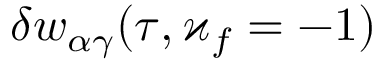<formula> <loc_0><loc_0><loc_500><loc_500>\delta w _ { \alpha \gamma } ( \tau , \varkappa _ { f } = - 1 )</formula> 